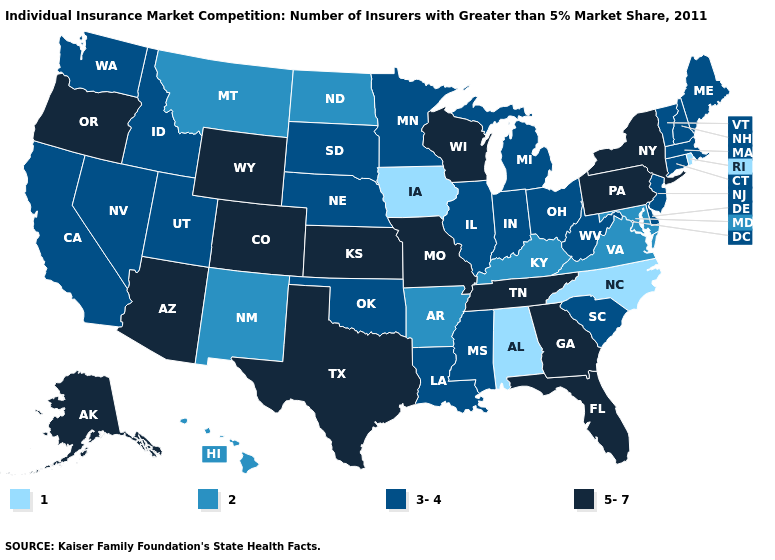Which states have the highest value in the USA?
Answer briefly. Alaska, Arizona, Colorado, Florida, Georgia, Kansas, Missouri, New York, Oregon, Pennsylvania, Tennessee, Texas, Wisconsin, Wyoming. What is the highest value in the Northeast ?
Short answer required. 5-7. What is the highest value in the MidWest ?
Quick response, please. 5-7. What is the lowest value in the USA?
Quick response, please. 1. Which states have the highest value in the USA?
Answer briefly. Alaska, Arizona, Colorado, Florida, Georgia, Kansas, Missouri, New York, Oregon, Pennsylvania, Tennessee, Texas, Wisconsin, Wyoming. Name the states that have a value in the range 5-7?
Be succinct. Alaska, Arizona, Colorado, Florida, Georgia, Kansas, Missouri, New York, Oregon, Pennsylvania, Tennessee, Texas, Wisconsin, Wyoming. Name the states that have a value in the range 3-4?
Be succinct. California, Connecticut, Delaware, Idaho, Illinois, Indiana, Louisiana, Maine, Massachusetts, Michigan, Minnesota, Mississippi, Nebraska, Nevada, New Hampshire, New Jersey, Ohio, Oklahoma, South Carolina, South Dakota, Utah, Vermont, Washington, West Virginia. Name the states that have a value in the range 5-7?
Concise answer only. Alaska, Arizona, Colorado, Florida, Georgia, Kansas, Missouri, New York, Oregon, Pennsylvania, Tennessee, Texas, Wisconsin, Wyoming. Name the states that have a value in the range 1?
Answer briefly. Alabama, Iowa, North Carolina, Rhode Island. What is the value of Kansas?
Concise answer only. 5-7. Does Oregon have the highest value in the West?
Write a very short answer. Yes. Among the states that border Georgia , which have the lowest value?
Be succinct. Alabama, North Carolina. What is the value of Arkansas?
Be succinct. 2. Does New Hampshire have the same value as Georgia?
Keep it brief. No. Does California have the lowest value in the West?
Keep it brief. No. 